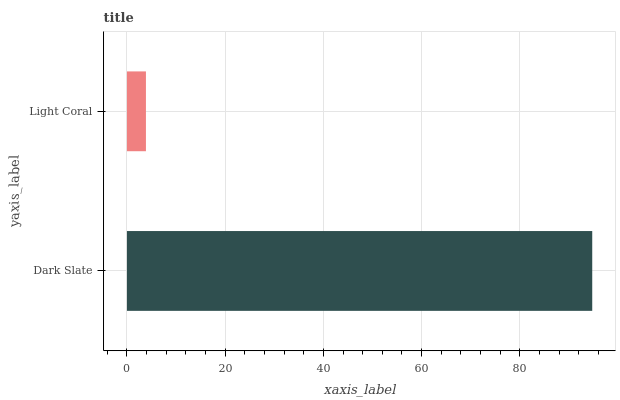Is Light Coral the minimum?
Answer yes or no. Yes. Is Dark Slate the maximum?
Answer yes or no. Yes. Is Light Coral the maximum?
Answer yes or no. No. Is Dark Slate greater than Light Coral?
Answer yes or no. Yes. Is Light Coral less than Dark Slate?
Answer yes or no. Yes. Is Light Coral greater than Dark Slate?
Answer yes or no. No. Is Dark Slate less than Light Coral?
Answer yes or no. No. Is Dark Slate the high median?
Answer yes or no. Yes. Is Light Coral the low median?
Answer yes or no. Yes. Is Light Coral the high median?
Answer yes or no. No. Is Dark Slate the low median?
Answer yes or no. No. 